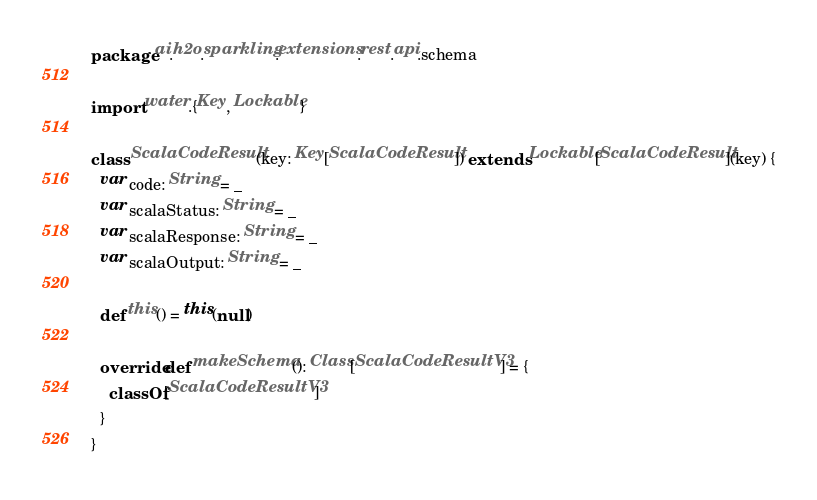Convert code to text. <code><loc_0><loc_0><loc_500><loc_500><_Scala_>package ai.h2o.sparkling.extensions.rest.api.schema

import water.{Key, Lockable}

class ScalaCodeResult(key: Key[ScalaCodeResult]) extends Lockable[ScalaCodeResult](key) {
  var code: String = _
  var scalaStatus: String = _
  var scalaResponse: String = _
  var scalaOutput: String = _

  def this() = this(null)

  override def makeSchema(): Class[ScalaCodeResultV3] = {
    classOf[ScalaCodeResultV3]
  }
}
</code> 